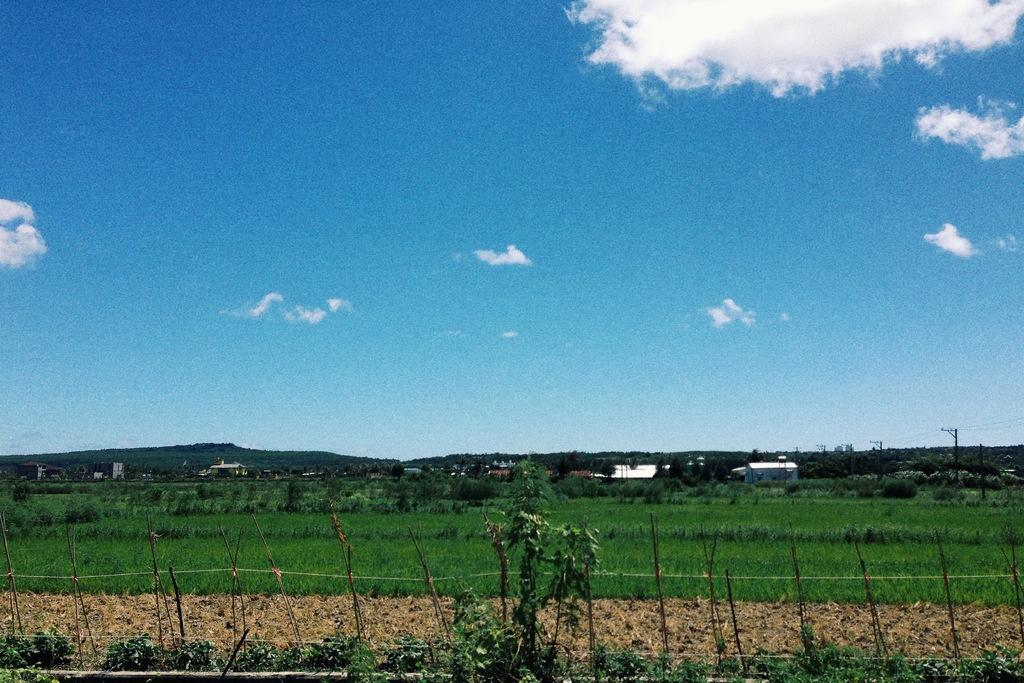What type of vegetation can be seen in the image? There is grass in the image. Are there any other natural elements visible in the image? Yes, there are trees in the image. What type of man-made structure can be seen in the image? There appears to be a fence in the image. What can be seen in the distance in the image? There are houses visible in the background of the image. What type of information is displayed in the image? There are current polls in the image. What is visible in the sky in the image? Clouds are present in the sky in the image. Can you see the plant smiling in the image? There is no plant or any object that can smile in the image. 